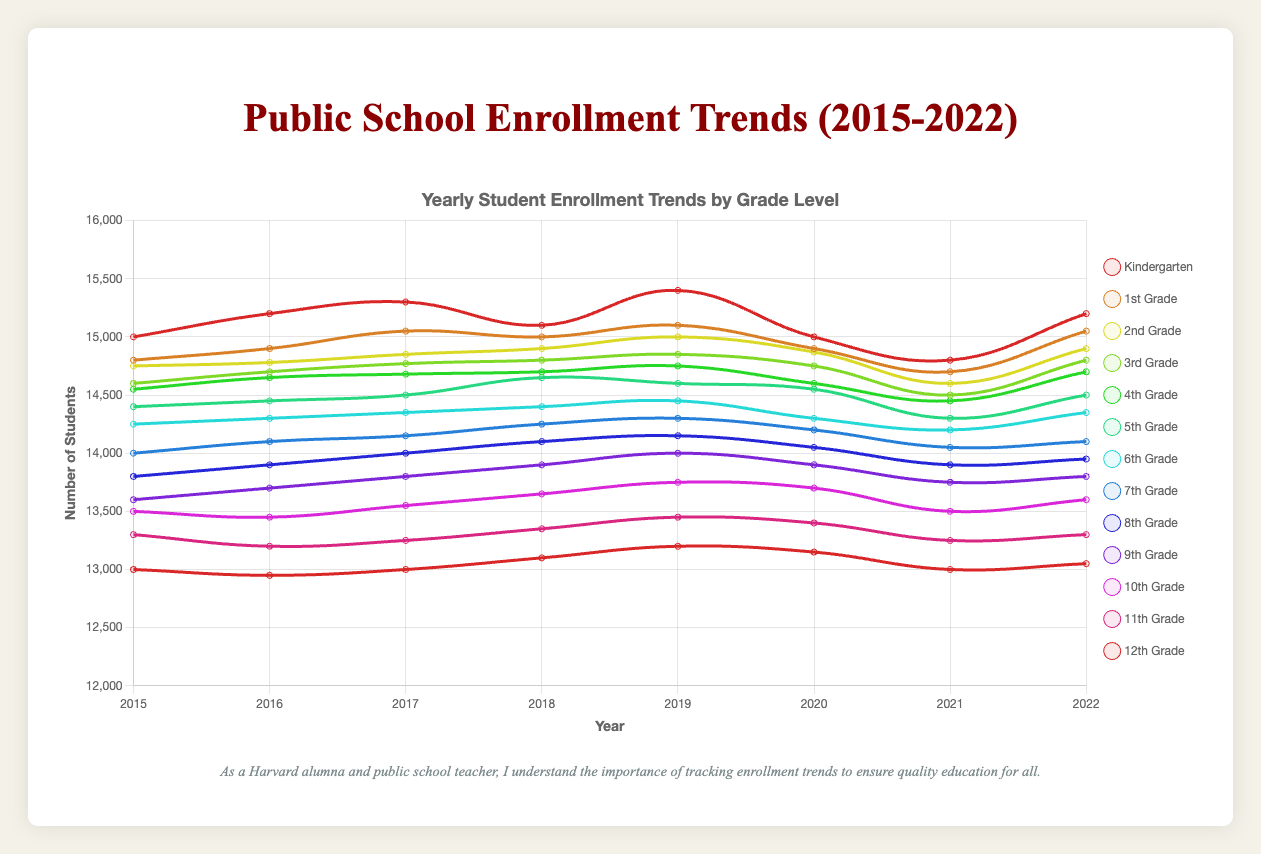What's the general trend of Kindergarten enrollment from 2015 to 2022? To determine the trend, observe the Kindergarten enrollment values at each year from 2015 to 2022. The trend appears to be slightly increasing with fluctuations, starting at 15000 in 2015 and ending at 15200 in 2022.
Answer: Slightly increasing Which grade had the highest enrollment in 2019? Look at the enrollment numbers for each grade in 2019. Kindergarten had the highest enrollment with 15400 students.
Answer: Kindergarten How did the enrollment in 4th Grade change from 2017 to 2022? Find the 4th Grade enrollment numbers in 2017 and 2022. In 2017, the enrollment was 14680, and in 2022, it was 14700. Therefore, the enrollment increased by 20 students.
Answer: Increased by 20 students What is the average enrollment for 5th Grade over the years 2015 to 2022? Calculate the average by summing the 5th Grade enrollment numbers over these years and dividing by the number of years. (14400 + 14450 + 14500 + 14650 + 14600 + 14550 + 14300 + 14500) / 8 = 14506.25
Answer: 14506.25 Between 9th Grade and 12th Grade, which had a higher decrease in enrollment from 2015 to 2022? Find the difference in enrollment for both grades over the years and compare. For 9th Grade: 13600 - 13800 = -200; For 12th Grade: 13000 - 13050 = -50. 12th Grade had a smaller decrease compared to 9th Grade.
Answer: 9th Grade Which grade had the smallest yearly fluctuation in enrollment numbers from 2015 to 2022? Observe the yearly data for each grade and determine the one with the most consistent numbers. 1st Grade has relatively small fluctuations, ranging from 14800 to 15100.
Answer: 1st Grade Did any grade level show a consistent decrease in enrollment from 2015 to 2022? Check each grade level's enrollment numbers for a pattern of consistent decrease. 11th Grade enrollment decreased consistently from 2015 (13300) to 2022 (13300).
Answer: 11th Grade How does the enrollment trend of 6th Grade compare to that of 8th Grade from 2015 to 2022? Observe the enrollment trends for 6th Grade and 8th Grade over the years. 6th Grade shows minor fluctuations and remains relatively stable, while 8th Grade shows a small but more consistent increase.
Answer: 8th Grade is more consistent What was the total enrollment across all grades in 2020? Sum up the enrollment numbers for all grades in 2020: 15000 + 14900 + 14870 + 14750 + 14600 + 14550 + 14300 + 14200 + 14050 + 13900 + 13700 + 13400 + 13150 = 174370
Answer: 174370 